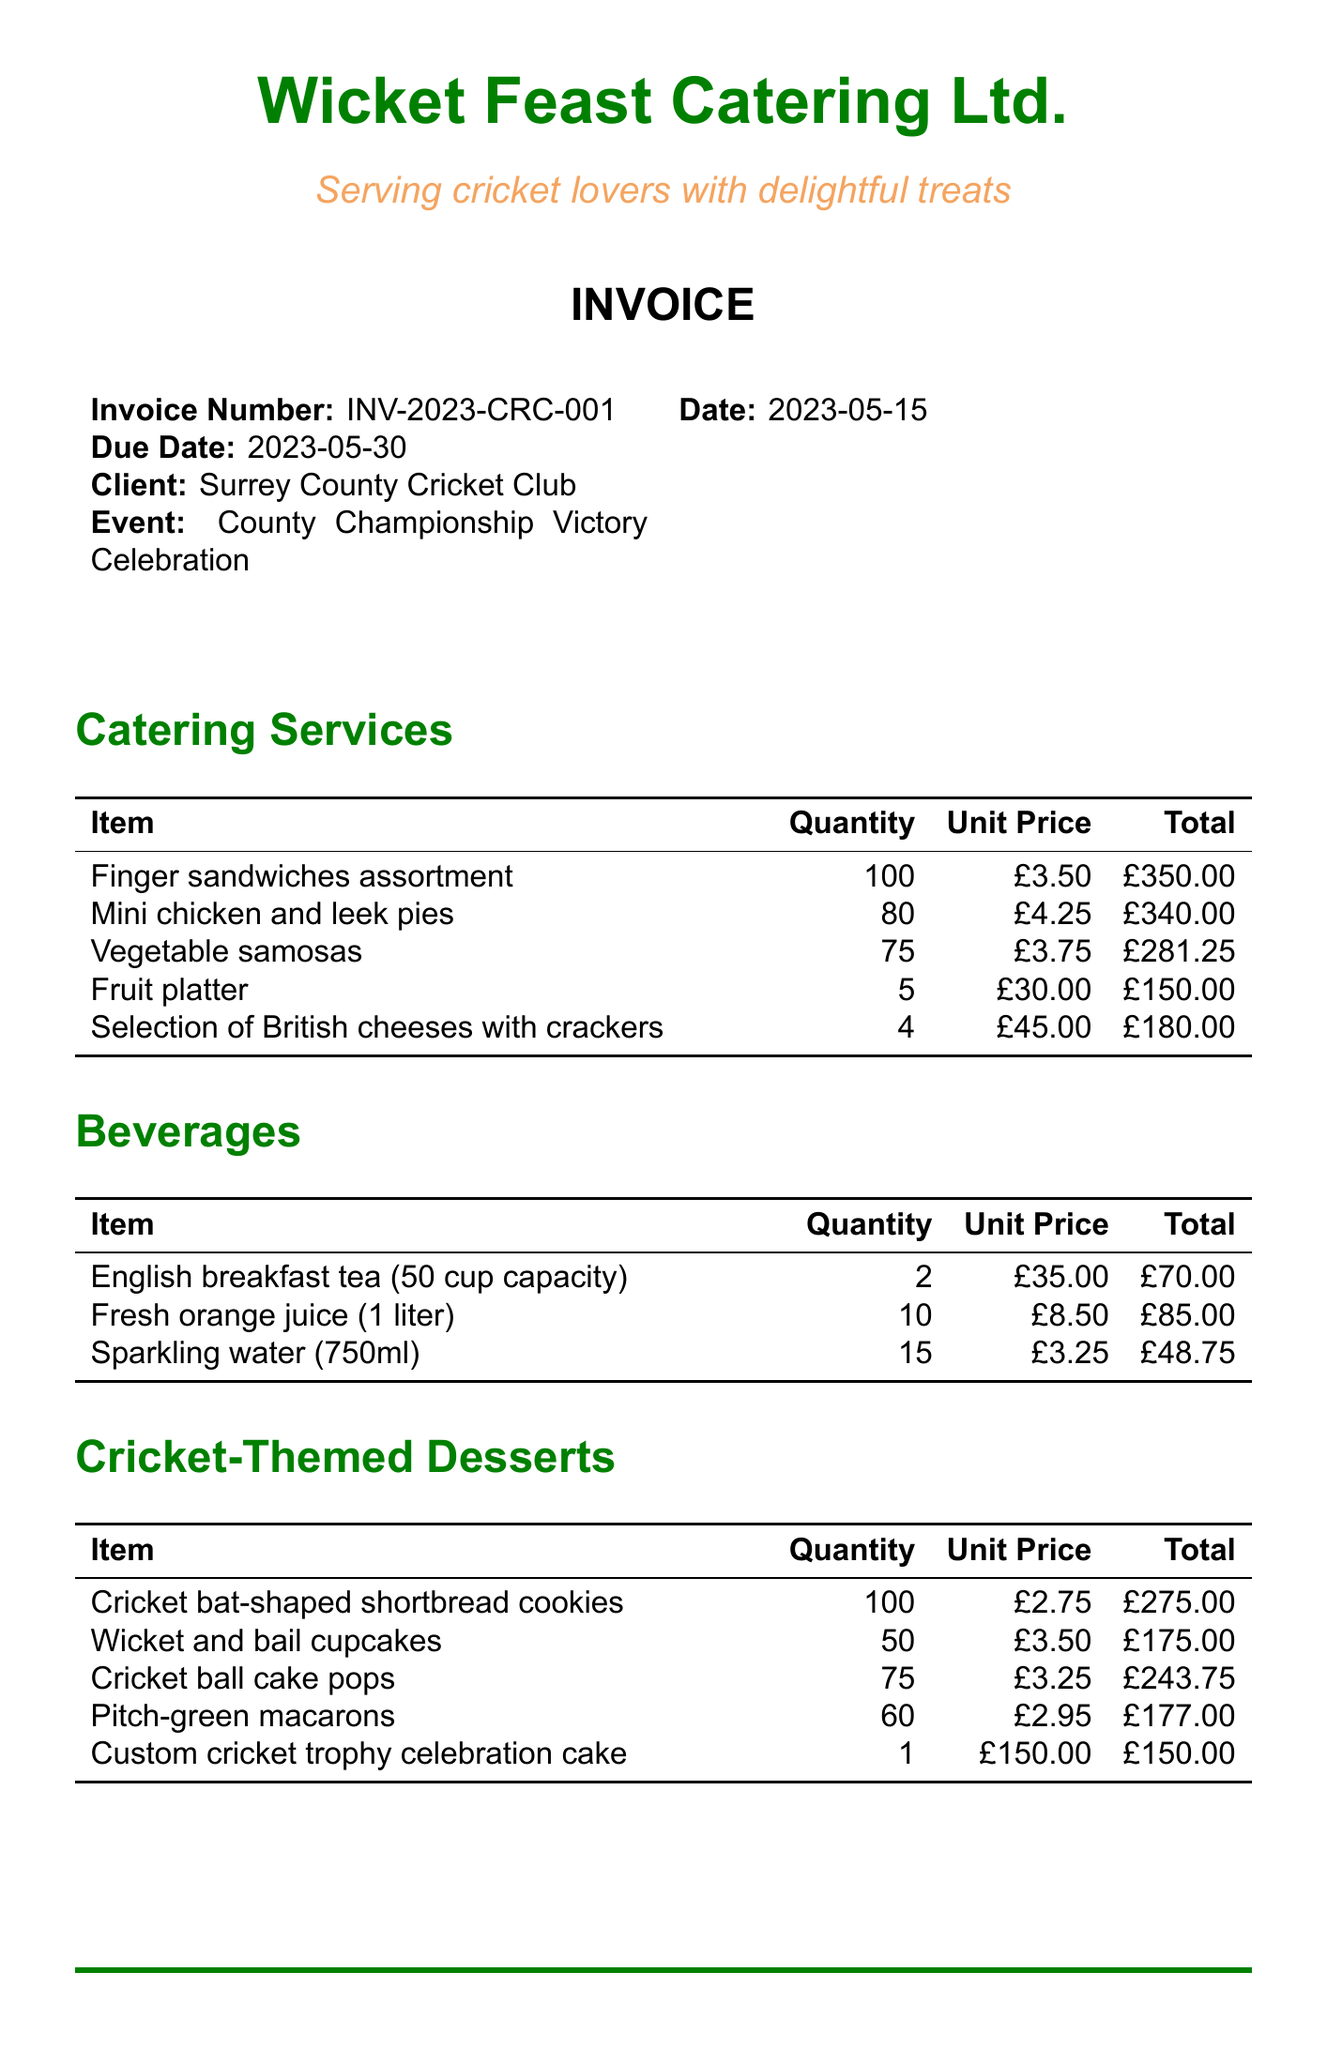What is the invoice number? The invoice number is specifically stated in the document under the invoice details section.
Answer: INV-2023-CRC-001 What is the total amount due? The total amount due is listed at the end of the invoice as part of the financial summary.
Answer: £3,780.90 How many vegetable samosas were ordered? The number of vegetable samosas is shown as the quantity under the catering services section.
Answer: 75 What is the unit price of the custom cricket trophy celebration cake? The unit price is specified alongside the item description in the cricket-themed desserts section.
Answer: £150.00 How many waitstaff were hired? The number of waitstaff can be found in the additional services section of the invoice.
Answer: 4 What is the subtotal of the invoice? The subtotal is calculated before tax and is provided in the financial summary at the end of the invoice.
Answer: £3,150.75 What is the due date for payment? The due date is mentioned in the invoice details section.
Answer: 2023-05-30 How many quantities of cricket bat-shaped shortbread cookies were provided? The quantity can be found listed under the cricket-themed desserts section.
Answer: 100 What color are the cricket-themed table decorations? The document details the decoration type but does not specify the color; instead, it confirms the inclusion of cricket-themed decorations.
Answer: Not specified 